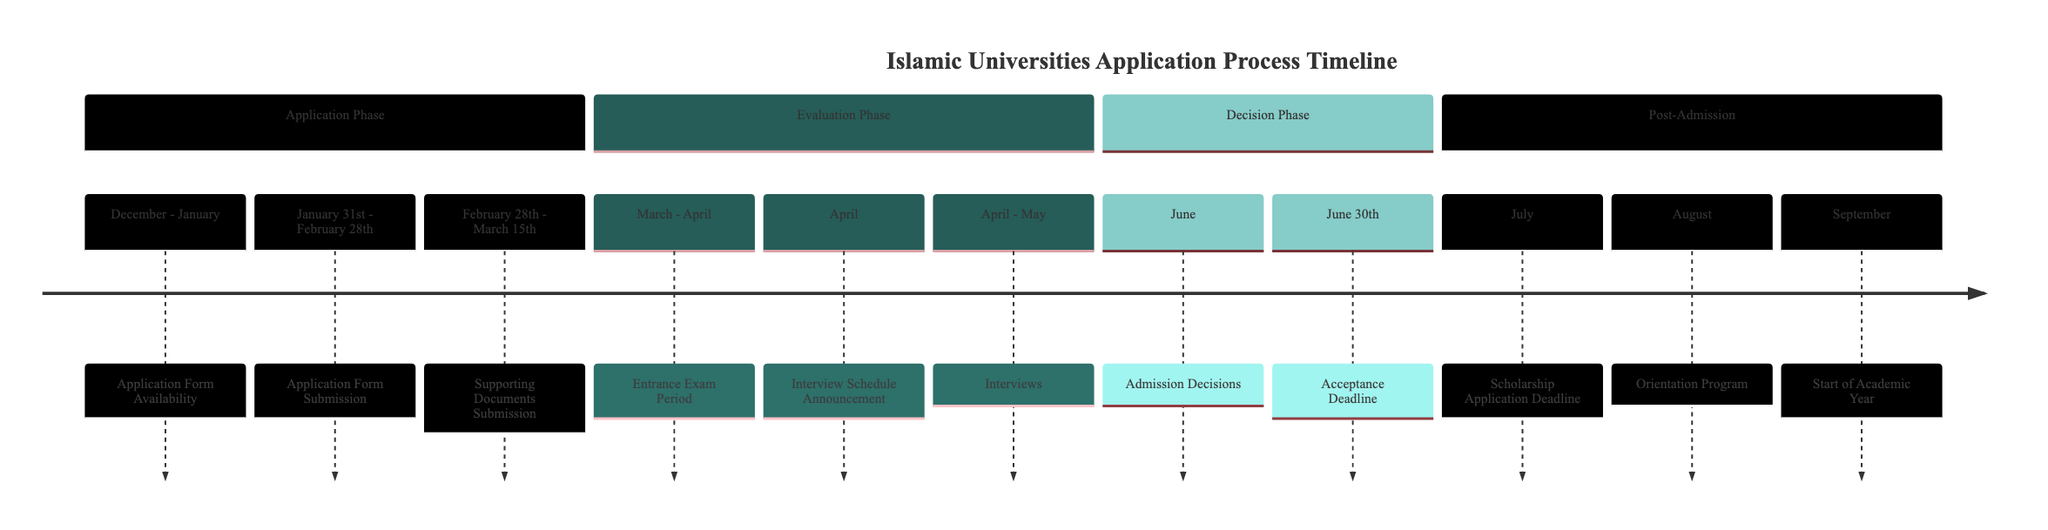What is the first event in the timeline? The timeline starts with the "Application Form Availability" event, which is listed at the beginning of the "Application Phase" section, indicating when application forms become available on university websites.
Answer: Application Form Availability When is the application form submission deadline? The application form submission deadline is shown as the range from "January 31st" to "February 28th" in the timeline. This indicates the specific dates by which applicants need to submit their completed application forms.
Answer: February 28th What month do interviews start? According to the timeline, interviews take place from "April" to "May." This means the first interviews occur in April.
Answer: April How long is the entrance exam period? The entrance exam period is specified in the timeline as occurring in "March - April," indicating that it spans over two months.
Answer: Two months What follows the admission decisions? The timeline indicates that "Acceptance Deadline" follows the "Admission Decisions" in June. This shows that students must confirm their attendance after receiving their admission decisions.
Answer: Acceptance Deadline In which month do new students attend the orientation program? The timeline specifies that the "Orientation Program" for new students occurs in "August," which is the month designated for these sessions.
Answer: August What event occurs just before the start of the academic year? The timeline shows that the "Orientation Program" takes place in August, and it is the event that occurs just before the "Start of Academic Year" in September.
Answer: Orientation Program How many distinct phases are shown in the timeline? The timeline organizes the process into four distinct phases: "Application Phase," "Evaluation Phase," "Decision Phase," and "Post-Admission," indicating a structured approach to the application process.
Answer: Four phases What is the typical date range for supporting documents submission? The timeline lists the "Supporting Documents Submission" date range as "February 28th - March 15th," indicating when applicants need to submit their transcripts and other documents.
Answer: March 15th 